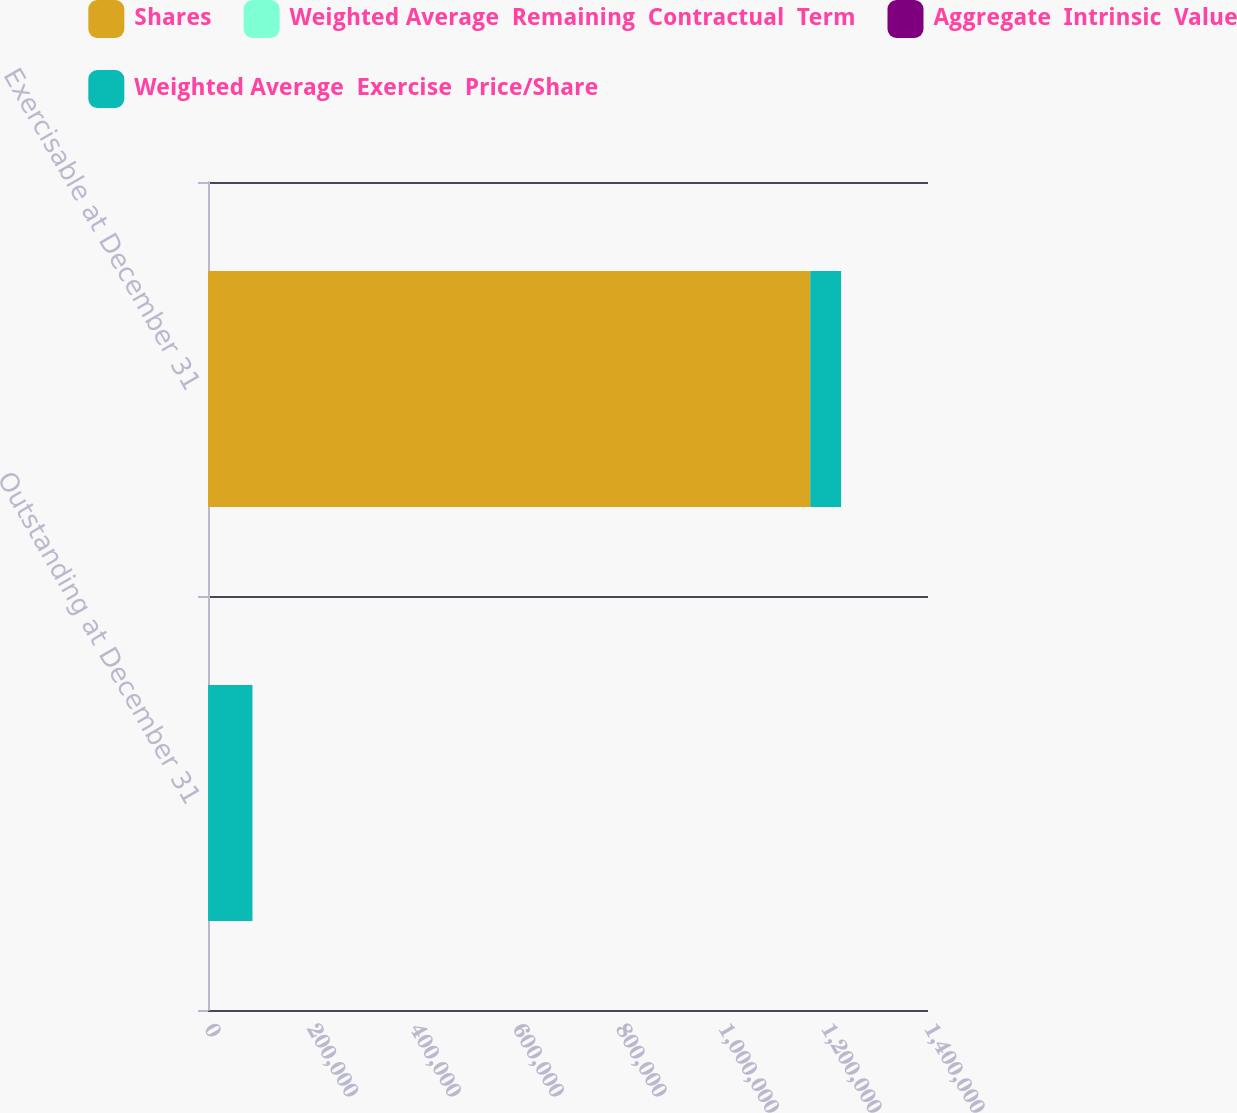Convert chart. <chart><loc_0><loc_0><loc_500><loc_500><stacked_bar_chart><ecel><fcel>Outstanding at December 31<fcel>Exercisable at December 31<nl><fcel>Shares<fcel>73.94<fcel>1.17095e+06<nl><fcel>Weighted Average  Remaining  Contractual  Term<fcel>61.75<fcel>49.1<nl><fcel>Aggregate  Intrinsic  Value<fcel>6.1<fcel>4.8<nl><fcel>Weighted Average  Exercise  Price/Share<fcel>86319<fcel>60007<nl></chart> 